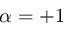Convert formula to latex. <formula><loc_0><loc_0><loc_500><loc_500>\alpha = + 1</formula> 